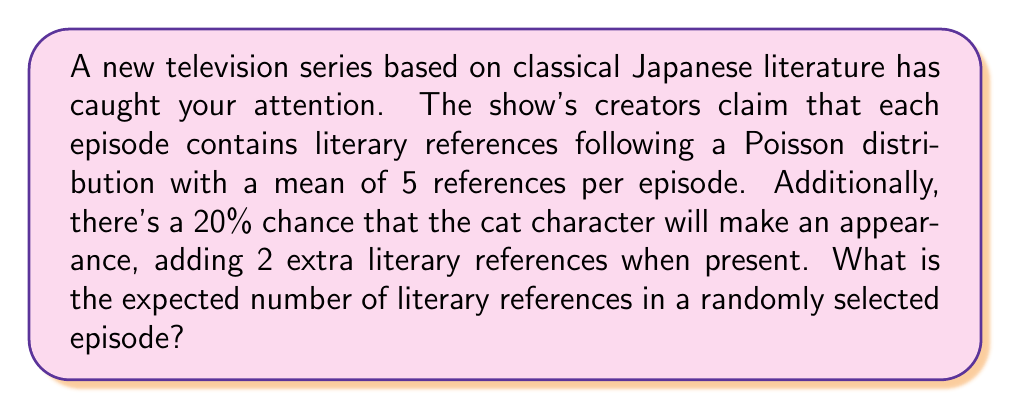Help me with this question. Let's approach this step-by-step:

1) Let X be the random variable representing the number of literary references in an episode without the cat's appearance.
   X ~ Poisson(λ = 5)

2) Let Y be the random variable representing the additional references when the cat appears.
   Y = 2 with probability 0.2, and Y = 0 with probability 0.8

3) The total number of references, Z, is the sum of X and Y.
   Z = X + Y

4) To find E[Z], we can use the linearity of expectation:
   E[Z] = E[X + Y] = E[X] + E[Y]

5) For a Poisson distribution, the expectation is equal to its parameter λ:
   E[X] = 5

6) For Y:
   E[Y] = 2 * 0.2 + 0 * 0.8 = 0.4

7) Therefore:
   E[Z] = E[X] + E[Y] = 5 + 0.4 = 5.4

Thus, the expected number of literary references in a randomly selected episode is 5.4.
Answer: 5.4 references 